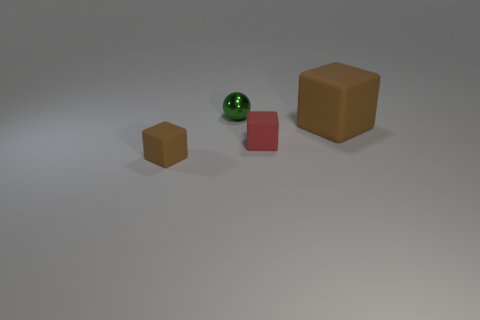Is the number of green metallic things that are on the right side of the red rubber thing greater than the number of big brown blocks?
Provide a succinct answer. No. Do the tiny brown cube and the tiny green ball have the same material?
Your answer should be very brief. No. How many other things are there of the same shape as the large thing?
Your answer should be compact. 2. Is there anything else that has the same material as the small red block?
Provide a succinct answer. Yes. What is the color of the small matte object that is on the right side of the brown thing in front of the thing to the right of the tiny red matte object?
Keep it short and to the point. Red. Do the brown object left of the metallic sphere and the metal object have the same shape?
Keep it short and to the point. No. How many green rubber spheres are there?
Your answer should be very brief. 0. How many purple metal things have the same size as the green shiny sphere?
Make the answer very short. 0. What is the green thing made of?
Offer a terse response. Metal. There is a metal thing; is it the same color as the rubber cube left of the sphere?
Your response must be concise. No. 